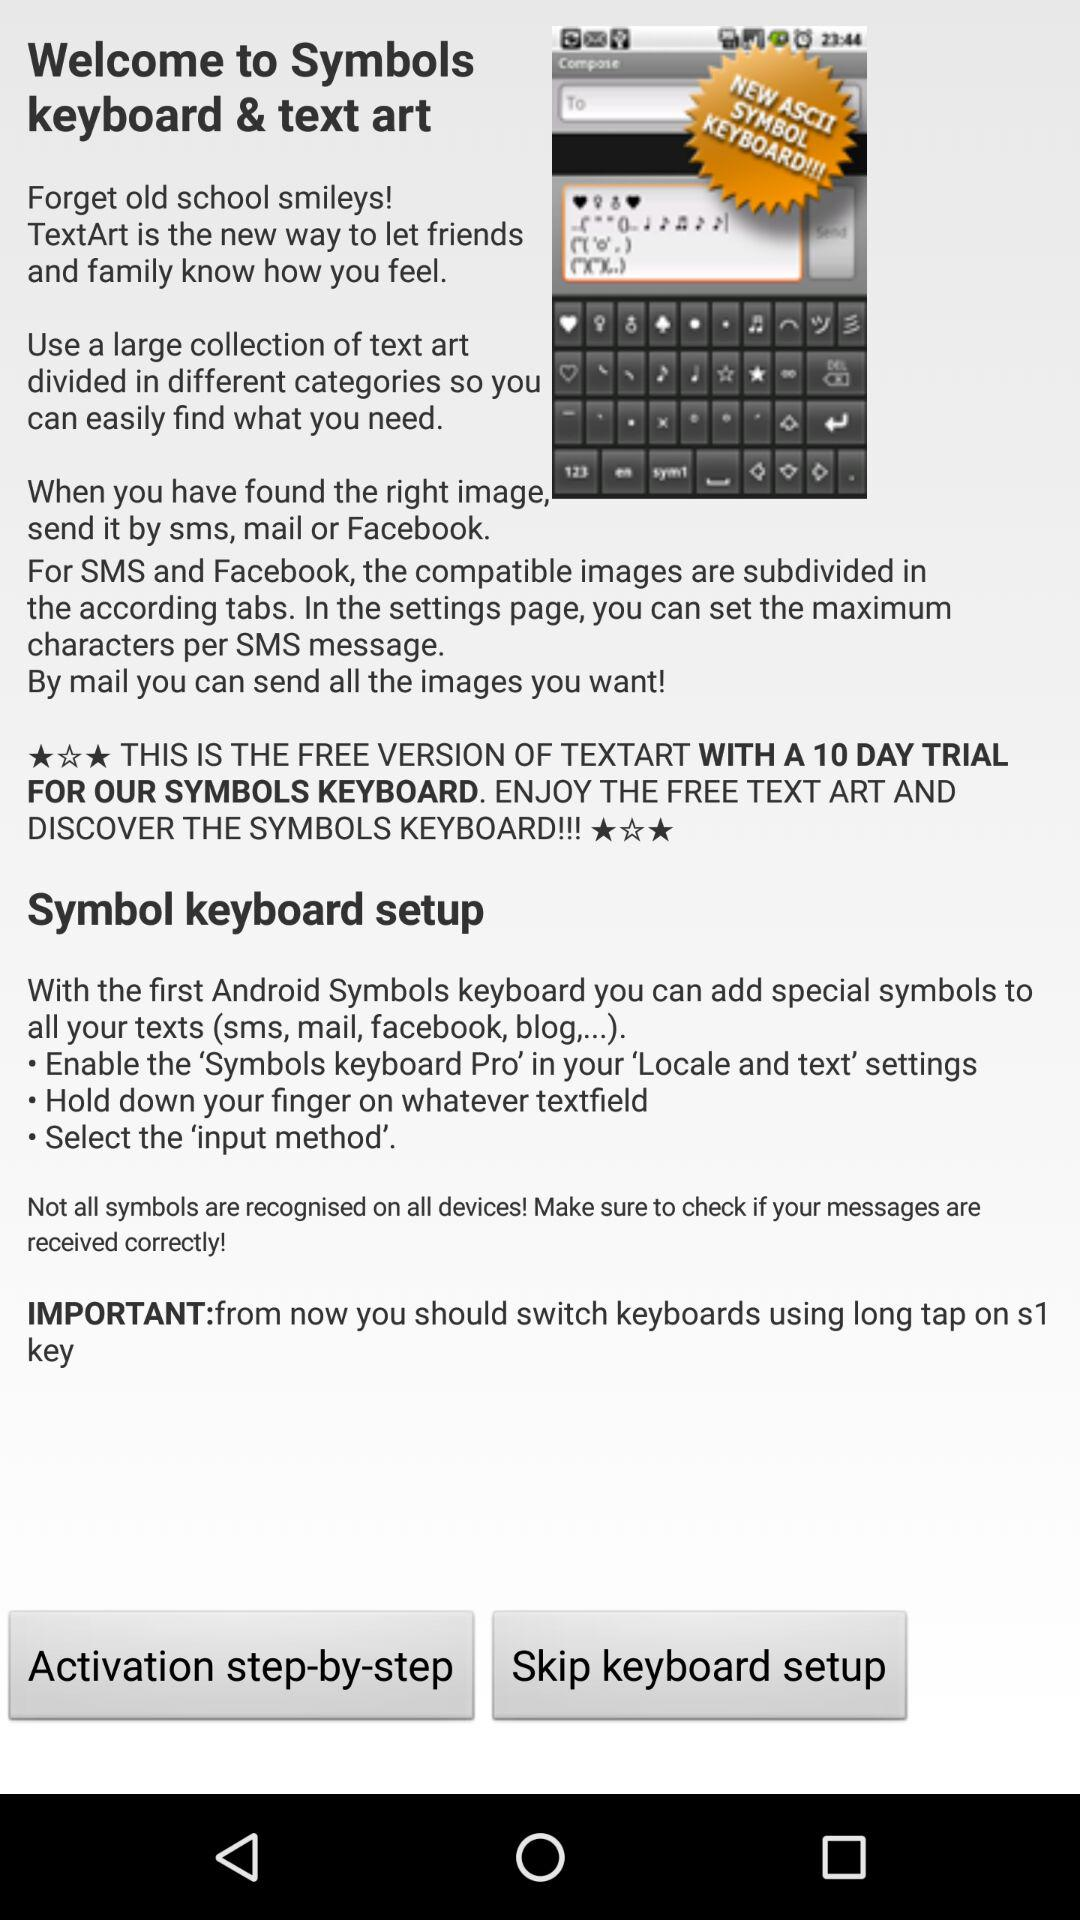How many symbols are on the keyboard?
When the provided information is insufficient, respond with <no answer>. <no answer> 